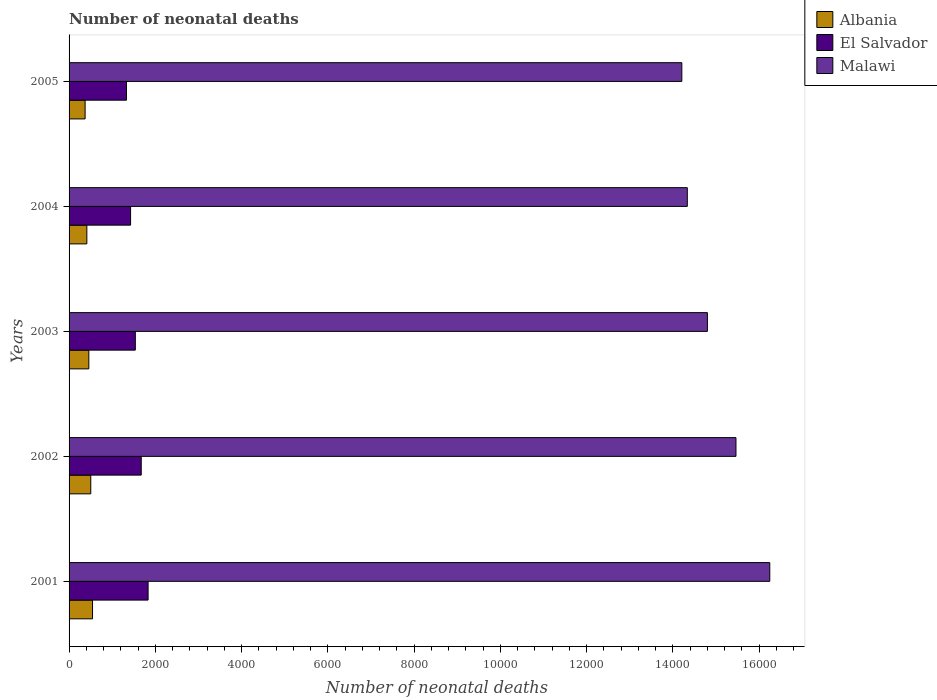How many different coloured bars are there?
Your answer should be very brief. 3. How many groups of bars are there?
Give a very brief answer. 5. How many bars are there on the 5th tick from the bottom?
Your answer should be very brief. 3. What is the label of the 3rd group of bars from the top?
Keep it short and to the point. 2003. What is the number of neonatal deaths in in El Salvador in 2005?
Your answer should be compact. 1331. Across all years, what is the maximum number of neonatal deaths in in Albania?
Offer a terse response. 544. Across all years, what is the minimum number of neonatal deaths in in Malawi?
Keep it short and to the point. 1.42e+04. In which year was the number of neonatal deaths in in El Salvador maximum?
Your response must be concise. 2001. What is the total number of neonatal deaths in in Albania in the graph?
Provide a short and direct response. 2289. What is the difference between the number of neonatal deaths in in El Salvador in 2004 and that in 2005?
Offer a very short reply. 95. What is the difference between the number of neonatal deaths in in Malawi in 2004 and the number of neonatal deaths in in El Salvador in 2002?
Offer a terse response. 1.27e+04. What is the average number of neonatal deaths in in Albania per year?
Ensure brevity in your answer.  457.8. In the year 2005, what is the difference between the number of neonatal deaths in in El Salvador and number of neonatal deaths in in Albania?
Ensure brevity in your answer.  959. What is the ratio of the number of neonatal deaths in in El Salvador in 2004 to that in 2005?
Provide a succinct answer. 1.07. Is the number of neonatal deaths in in Albania in 2003 less than that in 2004?
Offer a very short reply. No. What is the difference between the highest and the second highest number of neonatal deaths in in El Salvador?
Offer a very short reply. 159. What is the difference between the highest and the lowest number of neonatal deaths in in Albania?
Keep it short and to the point. 172. In how many years, is the number of neonatal deaths in in El Salvador greater than the average number of neonatal deaths in in El Salvador taken over all years?
Provide a succinct answer. 2. What does the 1st bar from the top in 2001 represents?
Provide a short and direct response. Malawi. What does the 3rd bar from the bottom in 2002 represents?
Make the answer very short. Malawi. How many years are there in the graph?
Offer a very short reply. 5. What is the difference between two consecutive major ticks on the X-axis?
Provide a short and direct response. 2000. Are the values on the major ticks of X-axis written in scientific E-notation?
Your response must be concise. No. How many legend labels are there?
Offer a very short reply. 3. How are the legend labels stacked?
Give a very brief answer. Vertical. What is the title of the graph?
Make the answer very short. Number of neonatal deaths. Does "Angola" appear as one of the legend labels in the graph?
Offer a very short reply. No. What is the label or title of the X-axis?
Keep it short and to the point. Number of neonatal deaths. What is the label or title of the Y-axis?
Provide a short and direct response. Years. What is the Number of neonatal deaths in Albania in 2001?
Provide a succinct answer. 544. What is the Number of neonatal deaths in El Salvador in 2001?
Your answer should be very brief. 1832. What is the Number of neonatal deaths in Malawi in 2001?
Keep it short and to the point. 1.62e+04. What is the Number of neonatal deaths in Albania in 2002?
Your answer should be compact. 503. What is the Number of neonatal deaths in El Salvador in 2002?
Offer a terse response. 1673. What is the Number of neonatal deaths of Malawi in 2002?
Give a very brief answer. 1.55e+04. What is the Number of neonatal deaths of Albania in 2003?
Provide a succinct answer. 458. What is the Number of neonatal deaths in El Salvador in 2003?
Your answer should be very brief. 1536. What is the Number of neonatal deaths of Malawi in 2003?
Your answer should be compact. 1.48e+04. What is the Number of neonatal deaths in Albania in 2004?
Offer a very short reply. 412. What is the Number of neonatal deaths of El Salvador in 2004?
Your answer should be compact. 1426. What is the Number of neonatal deaths of Malawi in 2004?
Your response must be concise. 1.43e+04. What is the Number of neonatal deaths in Albania in 2005?
Ensure brevity in your answer.  372. What is the Number of neonatal deaths of El Salvador in 2005?
Your response must be concise. 1331. What is the Number of neonatal deaths in Malawi in 2005?
Ensure brevity in your answer.  1.42e+04. Across all years, what is the maximum Number of neonatal deaths of Albania?
Your response must be concise. 544. Across all years, what is the maximum Number of neonatal deaths in El Salvador?
Provide a short and direct response. 1832. Across all years, what is the maximum Number of neonatal deaths of Malawi?
Your answer should be very brief. 1.62e+04. Across all years, what is the minimum Number of neonatal deaths in Albania?
Give a very brief answer. 372. Across all years, what is the minimum Number of neonatal deaths in El Salvador?
Give a very brief answer. 1331. Across all years, what is the minimum Number of neonatal deaths of Malawi?
Provide a succinct answer. 1.42e+04. What is the total Number of neonatal deaths of Albania in the graph?
Make the answer very short. 2289. What is the total Number of neonatal deaths of El Salvador in the graph?
Offer a very short reply. 7798. What is the total Number of neonatal deaths in Malawi in the graph?
Offer a very short reply. 7.50e+04. What is the difference between the Number of neonatal deaths of El Salvador in 2001 and that in 2002?
Offer a terse response. 159. What is the difference between the Number of neonatal deaths in Malawi in 2001 and that in 2002?
Keep it short and to the point. 784. What is the difference between the Number of neonatal deaths of Albania in 2001 and that in 2003?
Offer a terse response. 86. What is the difference between the Number of neonatal deaths in El Salvador in 2001 and that in 2003?
Ensure brevity in your answer.  296. What is the difference between the Number of neonatal deaths in Malawi in 2001 and that in 2003?
Your response must be concise. 1446. What is the difference between the Number of neonatal deaths in Albania in 2001 and that in 2004?
Your answer should be very brief. 132. What is the difference between the Number of neonatal deaths in El Salvador in 2001 and that in 2004?
Your answer should be very brief. 406. What is the difference between the Number of neonatal deaths of Malawi in 2001 and that in 2004?
Provide a succinct answer. 1912. What is the difference between the Number of neonatal deaths in Albania in 2001 and that in 2005?
Offer a terse response. 172. What is the difference between the Number of neonatal deaths in El Salvador in 2001 and that in 2005?
Your answer should be compact. 501. What is the difference between the Number of neonatal deaths in Malawi in 2001 and that in 2005?
Give a very brief answer. 2039. What is the difference between the Number of neonatal deaths in Albania in 2002 and that in 2003?
Provide a short and direct response. 45. What is the difference between the Number of neonatal deaths in El Salvador in 2002 and that in 2003?
Your answer should be compact. 137. What is the difference between the Number of neonatal deaths of Malawi in 2002 and that in 2003?
Provide a succinct answer. 662. What is the difference between the Number of neonatal deaths in Albania in 2002 and that in 2004?
Provide a short and direct response. 91. What is the difference between the Number of neonatal deaths of El Salvador in 2002 and that in 2004?
Provide a short and direct response. 247. What is the difference between the Number of neonatal deaths of Malawi in 2002 and that in 2004?
Your answer should be very brief. 1128. What is the difference between the Number of neonatal deaths of Albania in 2002 and that in 2005?
Provide a short and direct response. 131. What is the difference between the Number of neonatal deaths in El Salvador in 2002 and that in 2005?
Give a very brief answer. 342. What is the difference between the Number of neonatal deaths in Malawi in 2002 and that in 2005?
Ensure brevity in your answer.  1255. What is the difference between the Number of neonatal deaths in El Salvador in 2003 and that in 2004?
Provide a short and direct response. 110. What is the difference between the Number of neonatal deaths of Malawi in 2003 and that in 2004?
Offer a very short reply. 466. What is the difference between the Number of neonatal deaths of Albania in 2003 and that in 2005?
Provide a succinct answer. 86. What is the difference between the Number of neonatal deaths of El Salvador in 2003 and that in 2005?
Keep it short and to the point. 205. What is the difference between the Number of neonatal deaths in Malawi in 2003 and that in 2005?
Offer a terse response. 593. What is the difference between the Number of neonatal deaths in Malawi in 2004 and that in 2005?
Offer a terse response. 127. What is the difference between the Number of neonatal deaths of Albania in 2001 and the Number of neonatal deaths of El Salvador in 2002?
Provide a short and direct response. -1129. What is the difference between the Number of neonatal deaths of Albania in 2001 and the Number of neonatal deaths of Malawi in 2002?
Give a very brief answer. -1.49e+04. What is the difference between the Number of neonatal deaths in El Salvador in 2001 and the Number of neonatal deaths in Malawi in 2002?
Give a very brief answer. -1.36e+04. What is the difference between the Number of neonatal deaths of Albania in 2001 and the Number of neonatal deaths of El Salvador in 2003?
Offer a very short reply. -992. What is the difference between the Number of neonatal deaths of Albania in 2001 and the Number of neonatal deaths of Malawi in 2003?
Ensure brevity in your answer.  -1.43e+04. What is the difference between the Number of neonatal deaths in El Salvador in 2001 and the Number of neonatal deaths in Malawi in 2003?
Offer a terse response. -1.30e+04. What is the difference between the Number of neonatal deaths in Albania in 2001 and the Number of neonatal deaths in El Salvador in 2004?
Provide a succinct answer. -882. What is the difference between the Number of neonatal deaths in Albania in 2001 and the Number of neonatal deaths in Malawi in 2004?
Offer a terse response. -1.38e+04. What is the difference between the Number of neonatal deaths in El Salvador in 2001 and the Number of neonatal deaths in Malawi in 2004?
Provide a short and direct response. -1.25e+04. What is the difference between the Number of neonatal deaths in Albania in 2001 and the Number of neonatal deaths in El Salvador in 2005?
Ensure brevity in your answer.  -787. What is the difference between the Number of neonatal deaths in Albania in 2001 and the Number of neonatal deaths in Malawi in 2005?
Give a very brief answer. -1.37e+04. What is the difference between the Number of neonatal deaths of El Salvador in 2001 and the Number of neonatal deaths of Malawi in 2005?
Keep it short and to the point. -1.24e+04. What is the difference between the Number of neonatal deaths of Albania in 2002 and the Number of neonatal deaths of El Salvador in 2003?
Give a very brief answer. -1033. What is the difference between the Number of neonatal deaths of Albania in 2002 and the Number of neonatal deaths of Malawi in 2003?
Offer a terse response. -1.43e+04. What is the difference between the Number of neonatal deaths in El Salvador in 2002 and the Number of neonatal deaths in Malawi in 2003?
Your answer should be compact. -1.31e+04. What is the difference between the Number of neonatal deaths in Albania in 2002 and the Number of neonatal deaths in El Salvador in 2004?
Offer a terse response. -923. What is the difference between the Number of neonatal deaths in Albania in 2002 and the Number of neonatal deaths in Malawi in 2004?
Offer a terse response. -1.38e+04. What is the difference between the Number of neonatal deaths of El Salvador in 2002 and the Number of neonatal deaths of Malawi in 2004?
Your answer should be very brief. -1.27e+04. What is the difference between the Number of neonatal deaths in Albania in 2002 and the Number of neonatal deaths in El Salvador in 2005?
Your response must be concise. -828. What is the difference between the Number of neonatal deaths in Albania in 2002 and the Number of neonatal deaths in Malawi in 2005?
Your answer should be very brief. -1.37e+04. What is the difference between the Number of neonatal deaths in El Salvador in 2002 and the Number of neonatal deaths in Malawi in 2005?
Keep it short and to the point. -1.25e+04. What is the difference between the Number of neonatal deaths of Albania in 2003 and the Number of neonatal deaths of El Salvador in 2004?
Your answer should be compact. -968. What is the difference between the Number of neonatal deaths of Albania in 2003 and the Number of neonatal deaths of Malawi in 2004?
Provide a succinct answer. -1.39e+04. What is the difference between the Number of neonatal deaths in El Salvador in 2003 and the Number of neonatal deaths in Malawi in 2004?
Your answer should be very brief. -1.28e+04. What is the difference between the Number of neonatal deaths in Albania in 2003 and the Number of neonatal deaths in El Salvador in 2005?
Give a very brief answer. -873. What is the difference between the Number of neonatal deaths in Albania in 2003 and the Number of neonatal deaths in Malawi in 2005?
Provide a short and direct response. -1.37e+04. What is the difference between the Number of neonatal deaths of El Salvador in 2003 and the Number of neonatal deaths of Malawi in 2005?
Your response must be concise. -1.27e+04. What is the difference between the Number of neonatal deaths of Albania in 2004 and the Number of neonatal deaths of El Salvador in 2005?
Make the answer very short. -919. What is the difference between the Number of neonatal deaths in Albania in 2004 and the Number of neonatal deaths in Malawi in 2005?
Your response must be concise. -1.38e+04. What is the difference between the Number of neonatal deaths in El Salvador in 2004 and the Number of neonatal deaths in Malawi in 2005?
Your answer should be compact. -1.28e+04. What is the average Number of neonatal deaths in Albania per year?
Make the answer very short. 457.8. What is the average Number of neonatal deaths in El Salvador per year?
Make the answer very short. 1559.6. What is the average Number of neonatal deaths in Malawi per year?
Ensure brevity in your answer.  1.50e+04. In the year 2001, what is the difference between the Number of neonatal deaths in Albania and Number of neonatal deaths in El Salvador?
Keep it short and to the point. -1288. In the year 2001, what is the difference between the Number of neonatal deaths of Albania and Number of neonatal deaths of Malawi?
Your answer should be very brief. -1.57e+04. In the year 2001, what is the difference between the Number of neonatal deaths of El Salvador and Number of neonatal deaths of Malawi?
Provide a succinct answer. -1.44e+04. In the year 2002, what is the difference between the Number of neonatal deaths in Albania and Number of neonatal deaths in El Salvador?
Your answer should be very brief. -1170. In the year 2002, what is the difference between the Number of neonatal deaths of Albania and Number of neonatal deaths of Malawi?
Offer a terse response. -1.50e+04. In the year 2002, what is the difference between the Number of neonatal deaths in El Salvador and Number of neonatal deaths in Malawi?
Your answer should be very brief. -1.38e+04. In the year 2003, what is the difference between the Number of neonatal deaths of Albania and Number of neonatal deaths of El Salvador?
Offer a terse response. -1078. In the year 2003, what is the difference between the Number of neonatal deaths in Albania and Number of neonatal deaths in Malawi?
Your answer should be very brief. -1.43e+04. In the year 2003, what is the difference between the Number of neonatal deaths in El Salvador and Number of neonatal deaths in Malawi?
Provide a short and direct response. -1.33e+04. In the year 2004, what is the difference between the Number of neonatal deaths in Albania and Number of neonatal deaths in El Salvador?
Provide a short and direct response. -1014. In the year 2004, what is the difference between the Number of neonatal deaths in Albania and Number of neonatal deaths in Malawi?
Provide a succinct answer. -1.39e+04. In the year 2004, what is the difference between the Number of neonatal deaths of El Salvador and Number of neonatal deaths of Malawi?
Offer a terse response. -1.29e+04. In the year 2005, what is the difference between the Number of neonatal deaths in Albania and Number of neonatal deaths in El Salvador?
Ensure brevity in your answer.  -959. In the year 2005, what is the difference between the Number of neonatal deaths of Albania and Number of neonatal deaths of Malawi?
Your answer should be compact. -1.38e+04. In the year 2005, what is the difference between the Number of neonatal deaths of El Salvador and Number of neonatal deaths of Malawi?
Provide a succinct answer. -1.29e+04. What is the ratio of the Number of neonatal deaths of Albania in 2001 to that in 2002?
Ensure brevity in your answer.  1.08. What is the ratio of the Number of neonatal deaths of El Salvador in 2001 to that in 2002?
Provide a succinct answer. 1.09. What is the ratio of the Number of neonatal deaths in Malawi in 2001 to that in 2002?
Make the answer very short. 1.05. What is the ratio of the Number of neonatal deaths of Albania in 2001 to that in 2003?
Offer a very short reply. 1.19. What is the ratio of the Number of neonatal deaths in El Salvador in 2001 to that in 2003?
Provide a succinct answer. 1.19. What is the ratio of the Number of neonatal deaths of Malawi in 2001 to that in 2003?
Your answer should be compact. 1.1. What is the ratio of the Number of neonatal deaths in Albania in 2001 to that in 2004?
Ensure brevity in your answer.  1.32. What is the ratio of the Number of neonatal deaths in El Salvador in 2001 to that in 2004?
Give a very brief answer. 1.28. What is the ratio of the Number of neonatal deaths in Malawi in 2001 to that in 2004?
Provide a succinct answer. 1.13. What is the ratio of the Number of neonatal deaths in Albania in 2001 to that in 2005?
Provide a succinct answer. 1.46. What is the ratio of the Number of neonatal deaths in El Salvador in 2001 to that in 2005?
Offer a terse response. 1.38. What is the ratio of the Number of neonatal deaths of Malawi in 2001 to that in 2005?
Ensure brevity in your answer.  1.14. What is the ratio of the Number of neonatal deaths of Albania in 2002 to that in 2003?
Offer a very short reply. 1.1. What is the ratio of the Number of neonatal deaths in El Salvador in 2002 to that in 2003?
Your answer should be very brief. 1.09. What is the ratio of the Number of neonatal deaths in Malawi in 2002 to that in 2003?
Make the answer very short. 1.04. What is the ratio of the Number of neonatal deaths of Albania in 2002 to that in 2004?
Your answer should be very brief. 1.22. What is the ratio of the Number of neonatal deaths in El Salvador in 2002 to that in 2004?
Provide a short and direct response. 1.17. What is the ratio of the Number of neonatal deaths of Malawi in 2002 to that in 2004?
Your response must be concise. 1.08. What is the ratio of the Number of neonatal deaths of Albania in 2002 to that in 2005?
Your answer should be compact. 1.35. What is the ratio of the Number of neonatal deaths in El Salvador in 2002 to that in 2005?
Give a very brief answer. 1.26. What is the ratio of the Number of neonatal deaths in Malawi in 2002 to that in 2005?
Make the answer very short. 1.09. What is the ratio of the Number of neonatal deaths in Albania in 2003 to that in 2004?
Give a very brief answer. 1.11. What is the ratio of the Number of neonatal deaths of El Salvador in 2003 to that in 2004?
Your response must be concise. 1.08. What is the ratio of the Number of neonatal deaths of Malawi in 2003 to that in 2004?
Give a very brief answer. 1.03. What is the ratio of the Number of neonatal deaths of Albania in 2003 to that in 2005?
Offer a very short reply. 1.23. What is the ratio of the Number of neonatal deaths in El Salvador in 2003 to that in 2005?
Offer a terse response. 1.15. What is the ratio of the Number of neonatal deaths in Malawi in 2003 to that in 2005?
Keep it short and to the point. 1.04. What is the ratio of the Number of neonatal deaths of Albania in 2004 to that in 2005?
Offer a terse response. 1.11. What is the ratio of the Number of neonatal deaths in El Salvador in 2004 to that in 2005?
Provide a succinct answer. 1.07. What is the ratio of the Number of neonatal deaths in Malawi in 2004 to that in 2005?
Ensure brevity in your answer.  1.01. What is the difference between the highest and the second highest Number of neonatal deaths in Albania?
Your answer should be very brief. 41. What is the difference between the highest and the second highest Number of neonatal deaths in El Salvador?
Ensure brevity in your answer.  159. What is the difference between the highest and the second highest Number of neonatal deaths in Malawi?
Keep it short and to the point. 784. What is the difference between the highest and the lowest Number of neonatal deaths in Albania?
Your answer should be very brief. 172. What is the difference between the highest and the lowest Number of neonatal deaths of El Salvador?
Your answer should be compact. 501. What is the difference between the highest and the lowest Number of neonatal deaths in Malawi?
Offer a terse response. 2039. 